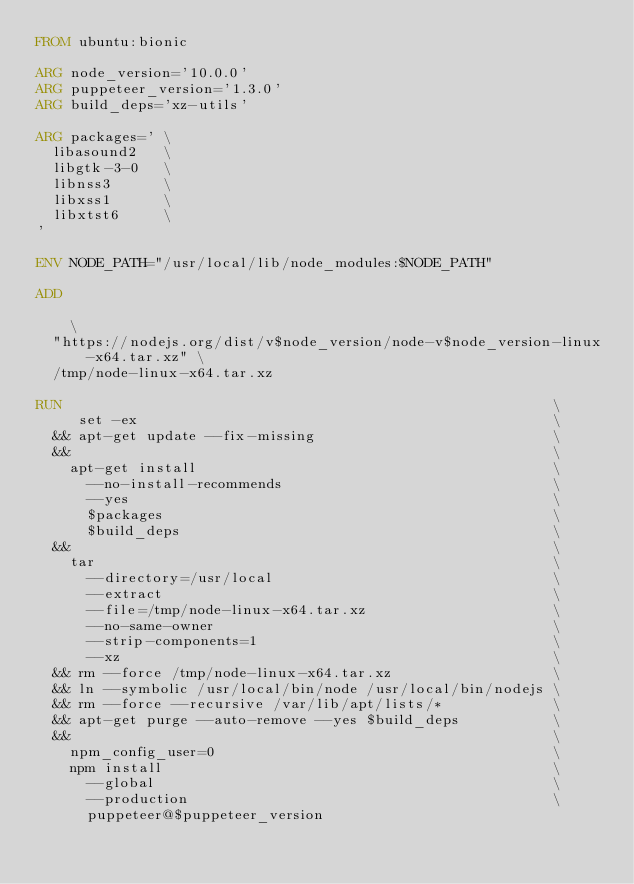<code> <loc_0><loc_0><loc_500><loc_500><_Dockerfile_>FROM ubuntu:bionic

ARG node_version='10.0.0'
ARG puppeteer_version='1.3.0'
ARG build_deps='xz-utils'

ARG packages=' \
  libasound2   \
  libgtk-3-0   \
  libnss3      \
  libxss1      \
  libxtst6     \
'

ENV NODE_PATH="/usr/local/lib/node_modules:$NODE_PATH"

ADD                                                                             \
  "https://nodejs.org/dist/v$node_version/node-v$node_version-linux-x64.tar.xz" \
  /tmp/node-linux-x64.tar.xz

RUN                                                          \
     set -ex                                                 \
  && apt-get update --fix-missing                            \
  &&                                                         \
    apt-get install                                          \
      --no-install-recommends                                \
      --yes                                                  \
      $packages                                              \
      $build_deps                                            \
  &&                                                         \
    tar                                                      \
      --directory=/usr/local                                 \
      --extract                                              \
      --file=/tmp/node-linux-x64.tar.xz                      \
      --no-same-owner                                        \
      --strip-components=1                                   \
      --xz                                                   \
  && rm --force /tmp/node-linux-x64.tar.xz                   \
  && ln --symbolic /usr/local/bin/node /usr/local/bin/nodejs \
  && rm --force --recursive /var/lib/apt/lists/*             \
  && apt-get purge --auto-remove --yes $build_deps           \
  &&                                                         \
    npm_config_user=0                                        \
    npm install                                              \
      --global                                               \
      --production                                           \
      puppeteer@$puppeteer_version
</code> 